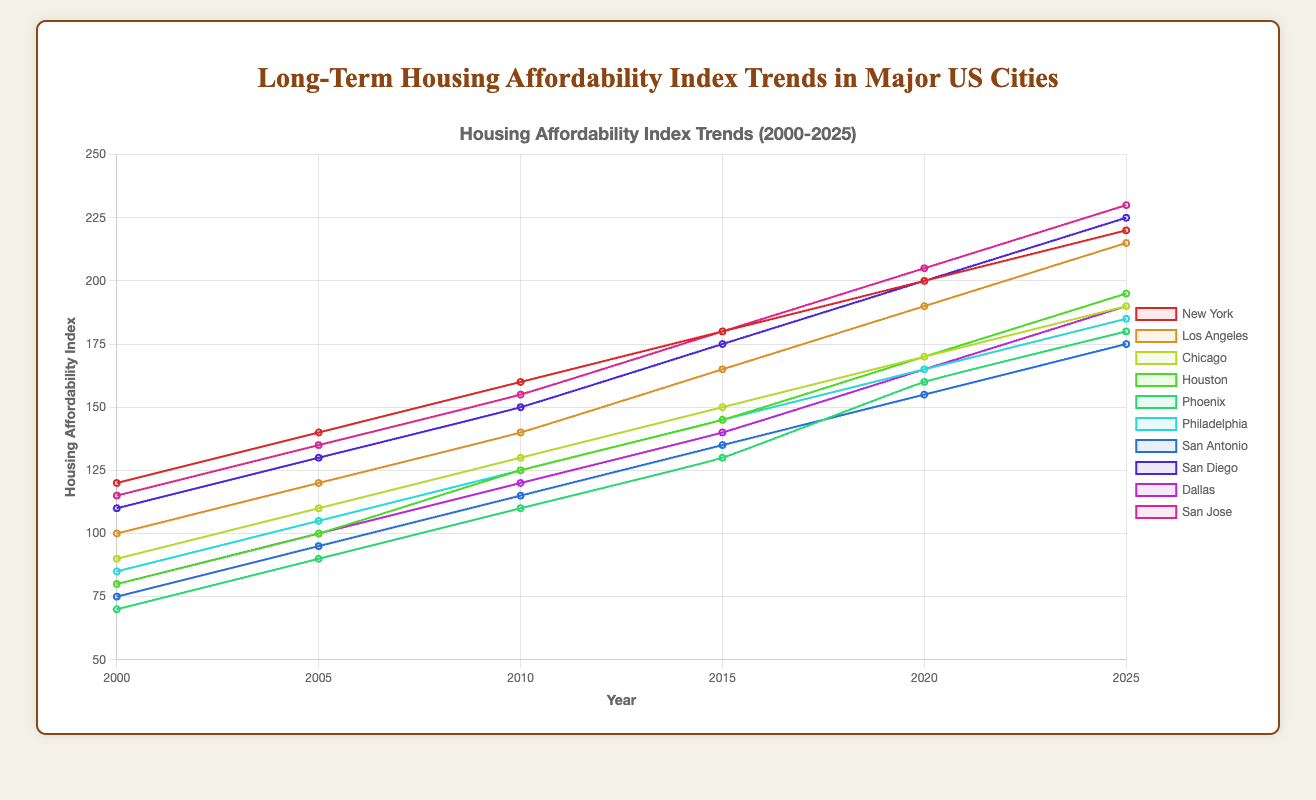What is the overall trend in the Housing Affordability Index for New York from 2000 to 2025? The Housing Affordability Index for New York shows a consistent increase from 120 in 2000 to 220 in 2025, indicating that housing is becoming less affordable over time
Answer: Increasing Which city had the highest Housing Affordability Index in 2010? By examining the plot, we can see that New York had the highest Housing Affordability Index in 2010 with a value of 160
Answer: New York How does the Housing Affordability Index of San Diego in 2025 compare to its value in 2000? San Diego’s Housing Affordability Index increased from 110 in 2000 to 225 in 2025, showing an overall increase of 115 over this period
Answer: Increased by 115 Which city experienced the largest increase in the Housing Affordability Index from 2000 to 2025? To determine this, we compare the differences for each city between 2000 and 2025. San Jose’s Index increased the most, from 115 to 230, a total increase of 115
Answer: San Jose What is the difference in the Housing Affordability Index between Chicago and Philadelphia in 2020? In 2020, Chicago had an index of 170 and Philadelphia had an index of 165, resulting in a difference of 170 - 165 = 5
Answer: 5 Is the Housing Affordability Index of Phoenix higher or lower than Dallas in 2025? By comparing the values for 2025, Phoenix has an index of 180 while Dallas has 190. Hence, Phoenix's index is lower than Dallas's
Answer: Lower What is the average Housing Affordability Index across all the cities in 2005? Adding up indexes for all cities in 2005 gives 140 + 120 + 110 + 100 + 90 + 105 + 95 + 130 + 100 + 135 = 1125. Dividing by 10 cities gives 1125 / 10 = 112.5
Answer: 112.5 Which city has the steepest upward trend in the Housing Affordability Index from 2000 to 2025? Looking at the slopes of the lines, San Diego's trend appears the steepest, going from 110 in 2000 to 225 in 2025, indicating the steepest upward trend
Answer: San Diego 